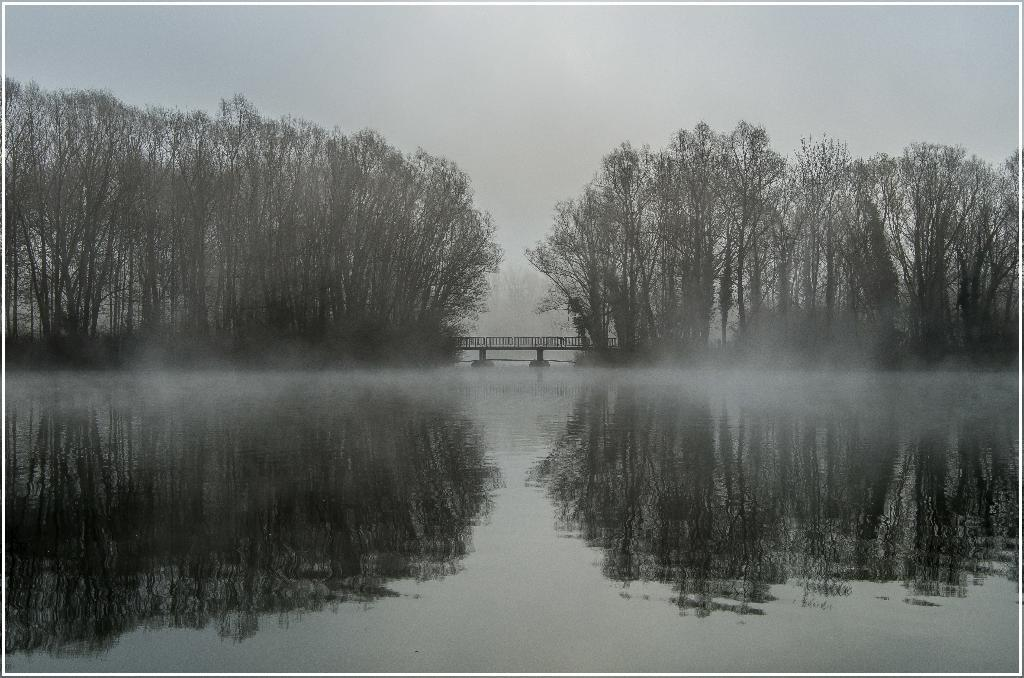What is at the bottom of the image? There is water at the bottom of the image. What can be seen in the middle of the image? There are trees and a bridge in the middle of the image. What is visible at the top of the image? The sky is visible at the top of the image. What song is being sung by the trees in the image? There is no indication that the trees are singing a song in the image. What is the rate of the water flow at the bottom of the image? The rate of the water flow cannot be determined from the image, as there is no information provided about the water's movement. 